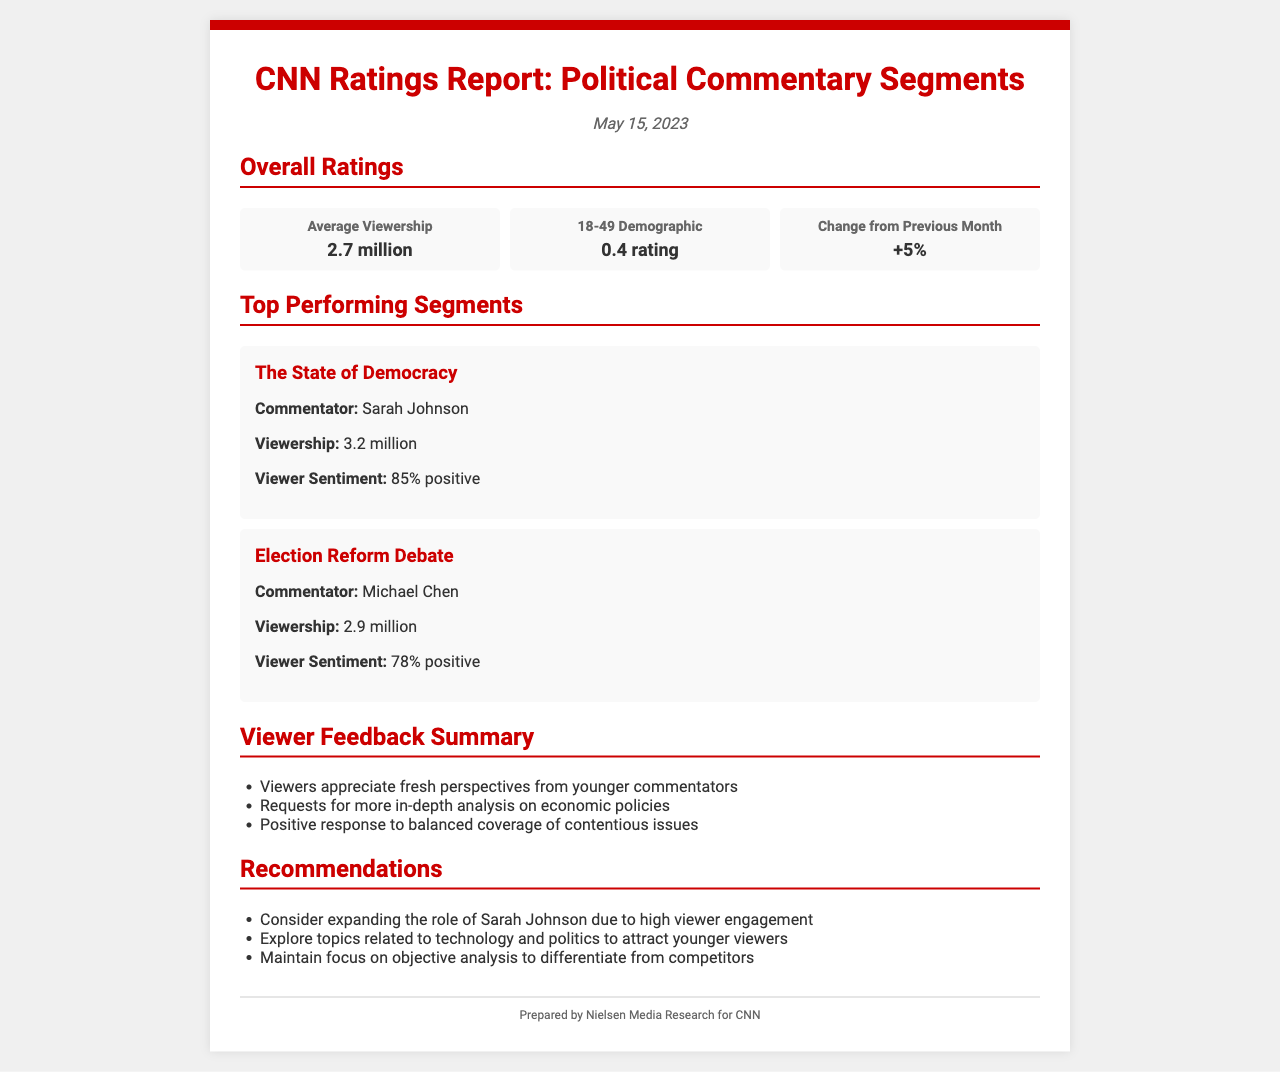What is the average viewership? The average viewership is stated in the overall ratings section as 2.7 million.
Answer: 2.7 million Who is the commentator for "The State of Democracy"? The document specifies that Sarah Johnson is the commentator for this segment.
Answer: Sarah Johnson What is the viewer sentiment for the "Election Reform Debate"? The viewer sentiment for this segment is 78% positive according to the ratings report.
Answer: 78% positive What change in viewership is reported from the previous month? The document notes a 5% increase in ratings from the previous month.
Answer: +5% What feedback do viewers have regarding younger commentators? The feedback mentions that viewers appreciate fresh perspectives from younger commentators.
Answer: Fresh perspectives from younger commentators 